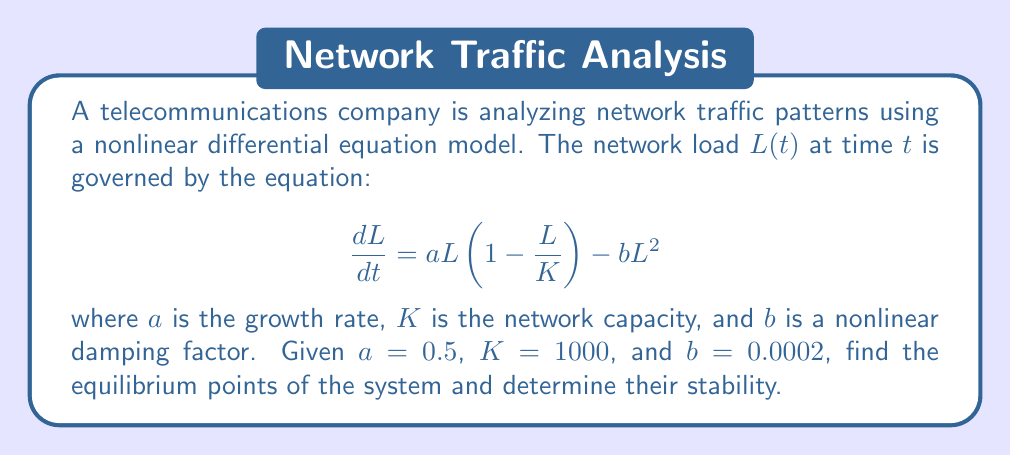Provide a solution to this math problem. To find the equilibrium points and determine their stability, we follow these steps:

1) Equilibrium points occur when $\frac{dL}{dt} = 0$. So, we solve:

   $$0 = aL(1-\frac{L}{K}) - bL^2$$

2) Factoring out $L$:

   $$0 = L(a(1-\frac{L}{K}) - bL)$$

3) We have two cases:
   
   Case 1: $L = 0$ (trivial equilibrium)
   
   Case 2: $a(1-\frac{L}{K}) - bL = 0$

4) For Case 2, we solve:

   $$a - \frac{aL}{K} - bL = 0$$
   $$a = L(\frac{a}{K} + b)$$
   $$L = \frac{a}{\frac{a}{K} + b}$$

5) Substituting the given values:

   $$L = \frac{0.5}{\frac{0.5}{1000} + 0.0002} \approx 714.29$$

6) To determine stability, we evaluate $\frac{d}{dL}(\frac{dL}{dt})$ at each equilibrium point:

   $$\frac{d}{dL}(\frac{dL}{dt}) = a - \frac{2aL}{K} - 2bL$$

7) At $L = 0$:
   
   $$\frac{d}{dL}(\frac{dL}{dt}) = a = 0.5 > 0$$
   
   This is unstable.

8) At $L \approx 714.29$:
   
   $$\frac{d}{dL}(\frac{dL}{dt}) = 0.5 - \frac{2(0.5)(714.29)}{1000} - 2(0.0002)(714.29) \approx -0.2857 < 0$$
   
   This is stable.
Answer: Equilibrium points: $L_1 = 0$ (unstable), $L_2 \approx 714.29$ (stable) 